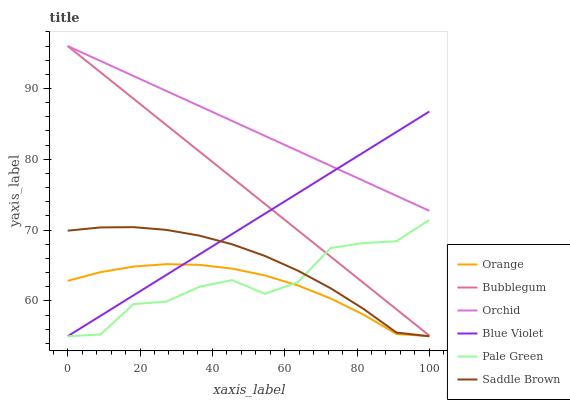Does Orange have the minimum area under the curve?
Answer yes or no. Yes. Does Orchid have the maximum area under the curve?
Answer yes or no. Yes. Does Pale Green have the minimum area under the curve?
Answer yes or no. No. Does Pale Green have the maximum area under the curve?
Answer yes or no. No. Is Orchid the smoothest?
Answer yes or no. Yes. Is Pale Green the roughest?
Answer yes or no. Yes. Is Orange the smoothest?
Answer yes or no. No. Is Orange the roughest?
Answer yes or no. No. Does Pale Green have the lowest value?
Answer yes or no. Yes. Does Orchid have the lowest value?
Answer yes or no. No. Does Orchid have the highest value?
Answer yes or no. Yes. Does Pale Green have the highest value?
Answer yes or no. No. Is Pale Green less than Orchid?
Answer yes or no. Yes. Is Bubblegum greater than Orange?
Answer yes or no. Yes. Does Orange intersect Pale Green?
Answer yes or no. Yes. Is Orange less than Pale Green?
Answer yes or no. No. Is Orange greater than Pale Green?
Answer yes or no. No. Does Pale Green intersect Orchid?
Answer yes or no. No. 